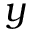<formula> <loc_0><loc_0><loc_500><loc_500>y</formula> 